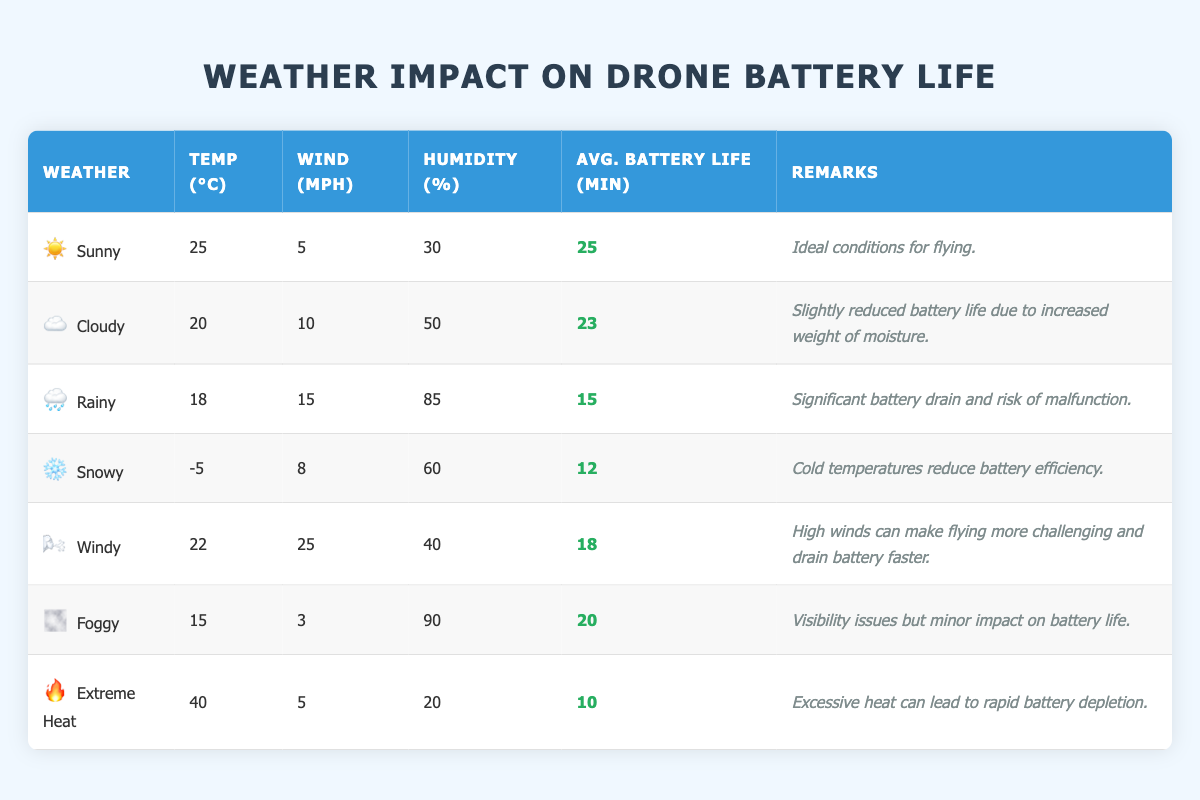What is the average battery life in sunny weather? The table indicates that the average battery life in sunny weather is listed as 25 minutes under the "Avg. Battery Life (min)" column.
Answer: 25 minutes What weather condition leads to the lowest battery life? The table shows that the snowy weather condition has an average battery life of 12 minutes, making it the lowest compared to other conditions.
Answer: Snowy Is battery life affected more by high wind or heavy rain? In the table, windy conditions have an average battery life of 18 minutes, while rainy conditions have a battery life of 15 minutes. Therefore, battery life is more affected by heavy rain.
Answer: Yes What is the difference in average battery life between sunny and extreme heat conditions? The average battery life for sunny conditions is 25 minutes, while for extreme heat it is 10 minutes. The difference is calculated as 25 - 10 = 15 minutes.
Answer: 15 minutes How does humidity levels correlate with battery life in rainy weather? In rainy conditions, the humidity is at 85%, and the average battery life is 15 minutes. While the table does not provide a direct comparison, it shows that high humidity correlates with a lower battery life.
Answer: Yes What is the average temperature across all weather conditions? To find the average temperature, add all the listed temperatures (25 + 20 + 18 - 5 + 22 + 15 + 40 = 135) and divide by the total number of weather conditions (7). Thus, the average temperature is 135/7 ≈ 19.29°C.
Answer: 19.29°C In which weather condition is battery life least affected by humidity? Foggy weather has a high humidity percentage of 90% but still maintains an average battery life of 20 minutes, making it less affected compared to rainy or snowy conditions.
Answer: Foggy What conclusions can be drawn about drone flying in extreme heat? The table remarks that excessive heat can lead to rapid battery depletion, evidenced by the average battery life dropping to 10 minutes. This indicates significant challenges for flying in such conditions.
Answer: Significant challenges What remark is given for cloudy weather conditions? The remark for cloudy weather indicates that there is slightly reduced battery life due to the increased weight of moisture, in addition to noting the average battery life of 23 minutes.
Answer: Slightly reduced battery life due to moisture 